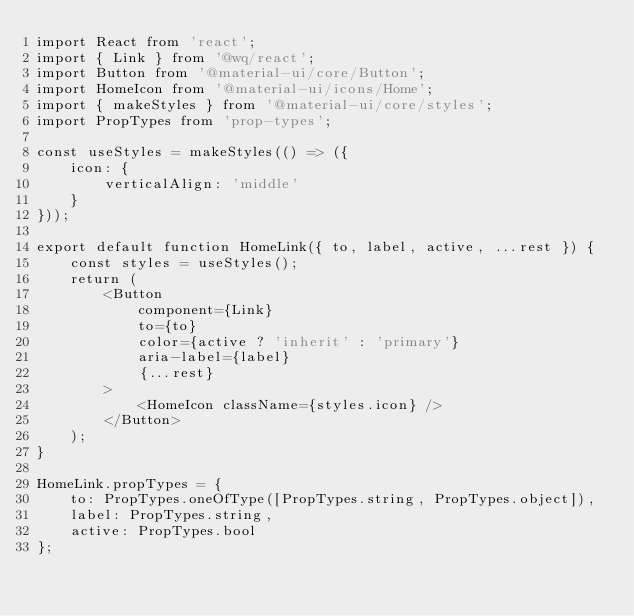<code> <loc_0><loc_0><loc_500><loc_500><_JavaScript_>import React from 'react';
import { Link } from '@wq/react';
import Button from '@material-ui/core/Button';
import HomeIcon from '@material-ui/icons/Home';
import { makeStyles } from '@material-ui/core/styles';
import PropTypes from 'prop-types';

const useStyles = makeStyles(() => ({
    icon: {
        verticalAlign: 'middle'
    }
}));

export default function HomeLink({ to, label, active, ...rest }) {
    const styles = useStyles();
    return (
        <Button
            component={Link}
            to={to}
            color={active ? 'inherit' : 'primary'}
            aria-label={label}
            {...rest}
        >
            <HomeIcon className={styles.icon} />
        </Button>
    );
}

HomeLink.propTypes = {
    to: PropTypes.oneOfType([PropTypes.string, PropTypes.object]),
    label: PropTypes.string,
    active: PropTypes.bool
};
</code> 